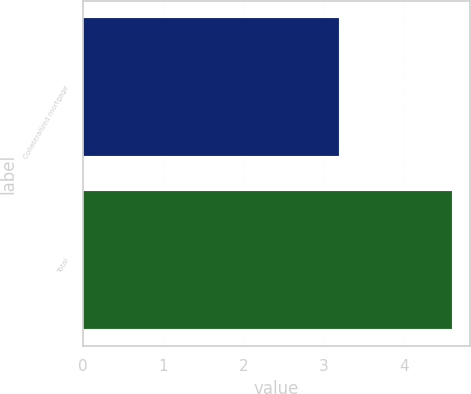Convert chart to OTSL. <chart><loc_0><loc_0><loc_500><loc_500><bar_chart><fcel>Collateralized mortgage<fcel>Total<nl><fcel>3.19<fcel>4.6<nl></chart> 